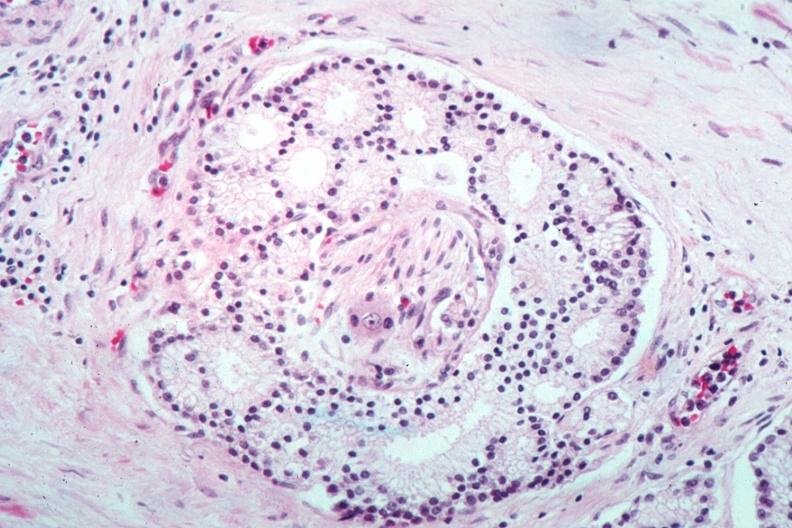does this image show nice photo of perineural invasion by well differentiated adenocarcinoma?
Answer the question using a single word or phrase. Yes 